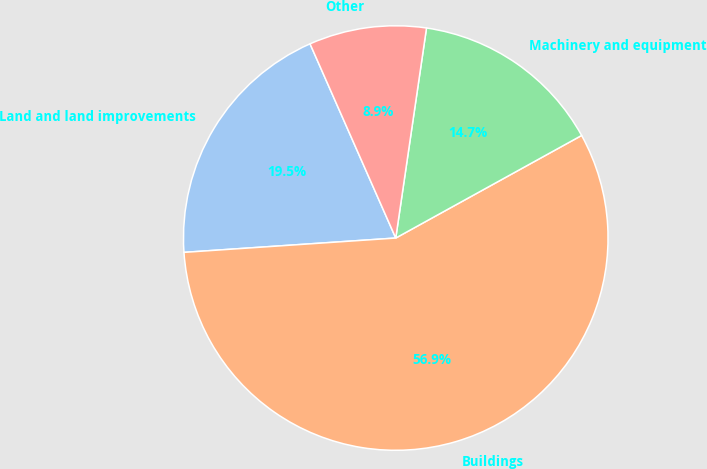<chart> <loc_0><loc_0><loc_500><loc_500><pie_chart><fcel>Land and land improvements<fcel>Buildings<fcel>Machinery and equipment<fcel>Other<nl><fcel>19.46%<fcel>56.95%<fcel>14.66%<fcel>8.93%<nl></chart> 